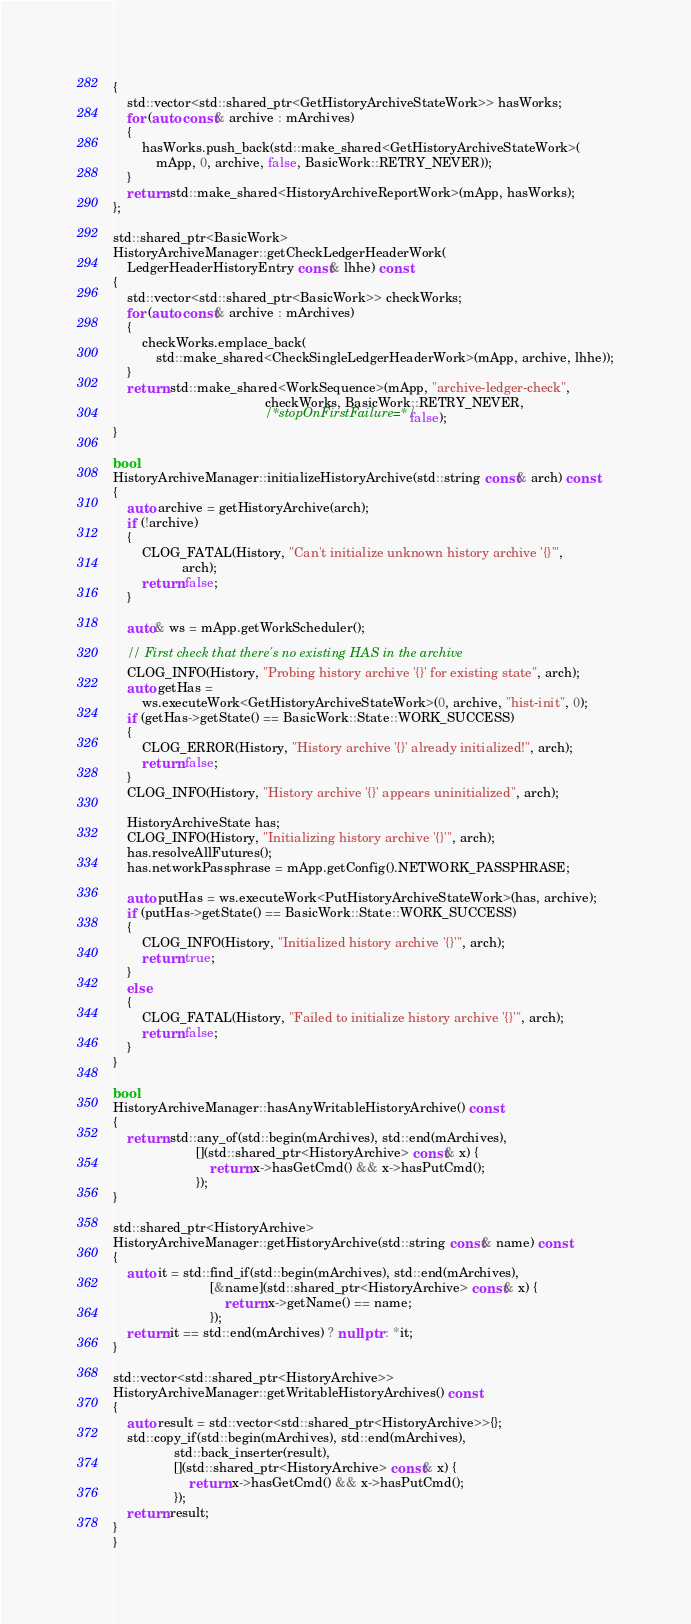Convert code to text. <code><loc_0><loc_0><loc_500><loc_500><_C++_>{
    std::vector<std::shared_ptr<GetHistoryArchiveStateWork>> hasWorks;
    for (auto const& archive : mArchives)
    {
        hasWorks.push_back(std::make_shared<GetHistoryArchiveStateWork>(
            mApp, 0, archive, false, BasicWork::RETRY_NEVER));
    }
    return std::make_shared<HistoryArchiveReportWork>(mApp, hasWorks);
};

std::shared_ptr<BasicWork>
HistoryArchiveManager::getCheckLedgerHeaderWork(
    LedgerHeaderHistoryEntry const& lhhe) const
{
    std::vector<std::shared_ptr<BasicWork>> checkWorks;
    for (auto const& archive : mArchives)
    {
        checkWorks.emplace_back(
            std::make_shared<CheckSingleLedgerHeaderWork>(mApp, archive, lhhe));
    }
    return std::make_shared<WorkSequence>(mApp, "archive-ledger-check",
                                          checkWorks, BasicWork::RETRY_NEVER,
                                          /*stopOnFirstFailure=*/false);
}

bool
HistoryArchiveManager::initializeHistoryArchive(std::string const& arch) const
{
    auto archive = getHistoryArchive(arch);
    if (!archive)
    {
        CLOG_FATAL(History, "Can't initialize unknown history archive '{}'",
                   arch);
        return false;
    }

    auto& ws = mApp.getWorkScheduler();

    // First check that there's no existing HAS in the archive
    CLOG_INFO(History, "Probing history archive '{}' for existing state", arch);
    auto getHas =
        ws.executeWork<GetHistoryArchiveStateWork>(0, archive, "hist-init", 0);
    if (getHas->getState() == BasicWork::State::WORK_SUCCESS)
    {
        CLOG_ERROR(History, "History archive '{}' already initialized!", arch);
        return false;
    }
    CLOG_INFO(History, "History archive '{}' appears uninitialized", arch);

    HistoryArchiveState has;
    CLOG_INFO(History, "Initializing history archive '{}'", arch);
    has.resolveAllFutures();
    has.networkPassphrase = mApp.getConfig().NETWORK_PASSPHRASE;

    auto putHas = ws.executeWork<PutHistoryArchiveStateWork>(has, archive);
    if (putHas->getState() == BasicWork::State::WORK_SUCCESS)
    {
        CLOG_INFO(History, "Initialized history archive '{}'", arch);
        return true;
    }
    else
    {
        CLOG_FATAL(History, "Failed to initialize history archive '{}'", arch);
        return false;
    }
}

bool
HistoryArchiveManager::hasAnyWritableHistoryArchive() const
{
    return std::any_of(std::begin(mArchives), std::end(mArchives),
                       [](std::shared_ptr<HistoryArchive> const& x) {
                           return x->hasGetCmd() && x->hasPutCmd();
                       });
}

std::shared_ptr<HistoryArchive>
HistoryArchiveManager::getHistoryArchive(std::string const& name) const
{
    auto it = std::find_if(std::begin(mArchives), std::end(mArchives),
                           [&name](std::shared_ptr<HistoryArchive> const& x) {
                               return x->getName() == name;
                           });
    return it == std::end(mArchives) ? nullptr : *it;
}

std::vector<std::shared_ptr<HistoryArchive>>
HistoryArchiveManager::getWritableHistoryArchives() const
{
    auto result = std::vector<std::shared_ptr<HistoryArchive>>{};
    std::copy_if(std::begin(mArchives), std::end(mArchives),
                 std::back_inserter(result),
                 [](std::shared_ptr<HistoryArchive> const& x) {
                     return x->hasGetCmd() && x->hasPutCmd();
                 });
    return result;
}
}
</code> 